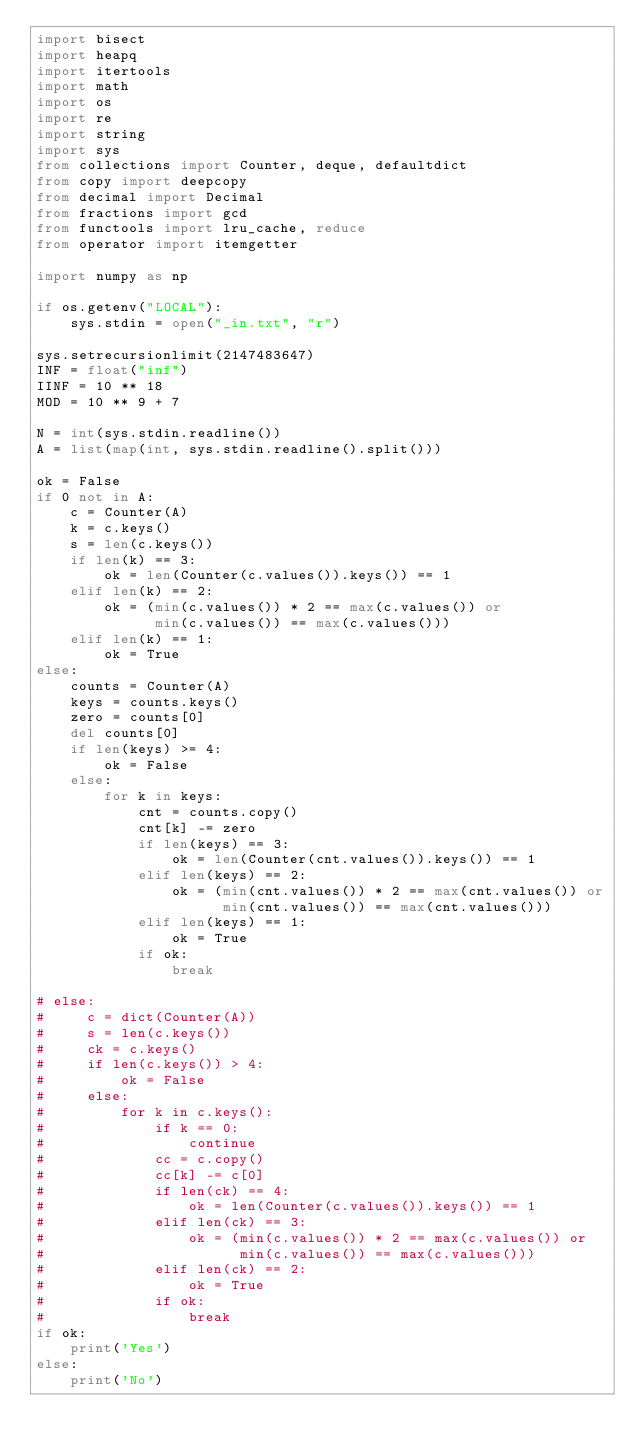<code> <loc_0><loc_0><loc_500><loc_500><_Python_>import bisect
import heapq
import itertools
import math
import os
import re
import string
import sys
from collections import Counter, deque, defaultdict
from copy import deepcopy
from decimal import Decimal
from fractions import gcd
from functools import lru_cache, reduce
from operator import itemgetter

import numpy as np

if os.getenv("LOCAL"):
    sys.stdin = open("_in.txt", "r")

sys.setrecursionlimit(2147483647)
INF = float("inf")
IINF = 10 ** 18
MOD = 10 ** 9 + 7

N = int(sys.stdin.readline())
A = list(map(int, sys.stdin.readline().split()))

ok = False
if 0 not in A:
    c = Counter(A)
    k = c.keys()
    s = len(c.keys())
    if len(k) == 3:
        ok = len(Counter(c.values()).keys()) == 1
    elif len(k) == 2:
        ok = (min(c.values()) * 2 == max(c.values()) or
              min(c.values()) == max(c.values()))
    elif len(k) == 1:
        ok = True
else:
    counts = Counter(A)
    keys = counts.keys()
    zero = counts[0]
    del counts[0]
    if len(keys) >= 4:
        ok = False
    else:
        for k in keys:
            cnt = counts.copy()
            cnt[k] -= zero
            if len(keys) == 3:
                ok = len(Counter(cnt.values()).keys()) == 1
            elif len(keys) == 2:
                ok = (min(cnt.values()) * 2 == max(cnt.values()) or
                      min(cnt.values()) == max(cnt.values()))
            elif len(keys) == 1:
                ok = True
            if ok:
                break

# else:
#     c = dict(Counter(A))
#     s = len(c.keys())
#     ck = c.keys()
#     if len(c.keys()) > 4:
#         ok = False
#     else:
#         for k in c.keys():
#             if k == 0:
#                 continue
#             cc = c.copy()
#             cc[k] -= c[0]
#             if len(ck) == 4:
#                 ok = len(Counter(c.values()).keys()) == 1
#             elif len(ck) == 3:
#                 ok = (min(c.values()) * 2 == max(c.values()) or
#                       min(c.values()) == max(c.values()))
#             elif len(ck) == 2:
#                 ok = True
#             if ok:
#                 break
if ok:
    print('Yes')
else:
    print('No')
</code> 